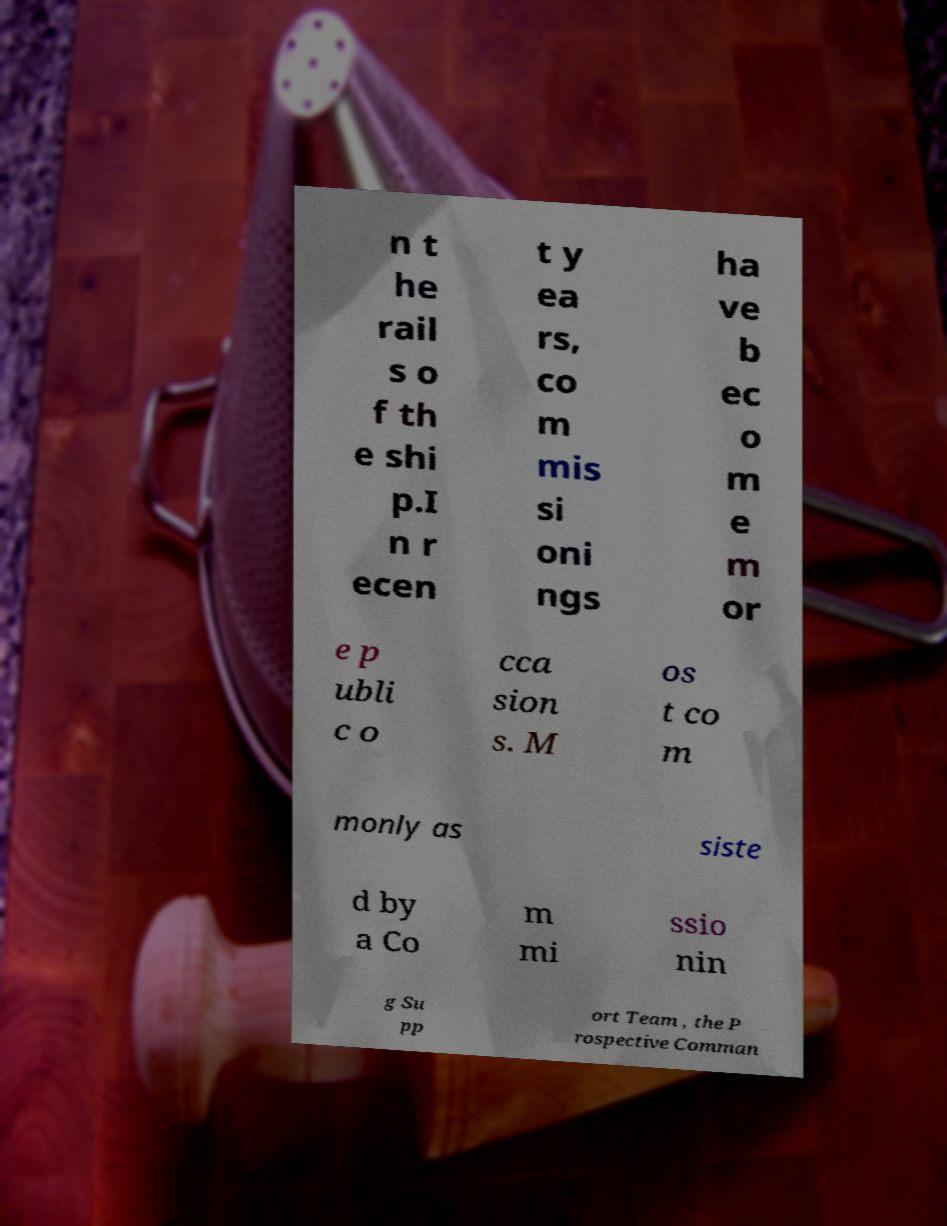What messages or text are displayed in this image? I need them in a readable, typed format. n t he rail s o f th e shi p.I n r ecen t y ea rs, co m mis si oni ngs ha ve b ec o m e m or e p ubli c o cca sion s. M os t co m monly as siste d by a Co m mi ssio nin g Su pp ort Team , the P rospective Comman 